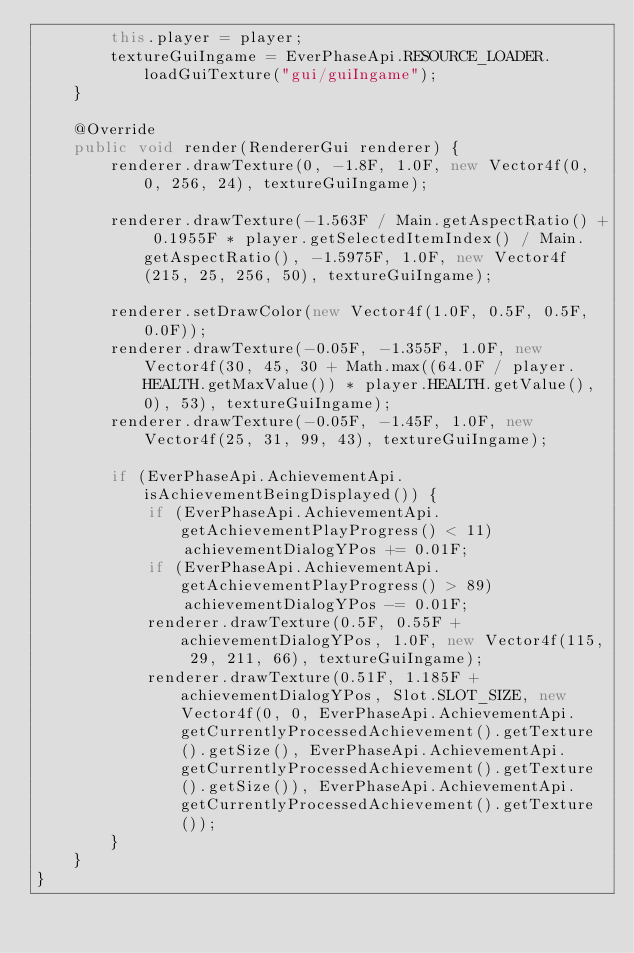<code> <loc_0><loc_0><loc_500><loc_500><_Java_>        this.player = player;
        textureGuiIngame = EverPhaseApi.RESOURCE_LOADER.loadGuiTexture("gui/guiIngame");
    }

    @Override
    public void render(RendererGui renderer) {
        renderer.drawTexture(0, -1.8F, 1.0F, new Vector4f(0, 0, 256, 24), textureGuiIngame);

        renderer.drawTexture(-1.563F / Main.getAspectRatio() + 0.1955F * player.getSelectedItemIndex() / Main.getAspectRatio(), -1.5975F, 1.0F, new Vector4f(215, 25, 256, 50), textureGuiIngame);

        renderer.setDrawColor(new Vector4f(1.0F, 0.5F, 0.5F, 0.0F));
        renderer.drawTexture(-0.05F, -1.355F, 1.0F, new Vector4f(30, 45, 30 + Math.max((64.0F / player.HEALTH.getMaxValue()) * player.HEALTH.getValue(), 0), 53), textureGuiIngame);
        renderer.drawTexture(-0.05F, -1.45F, 1.0F, new Vector4f(25, 31, 99, 43), textureGuiIngame);

        if (EverPhaseApi.AchievementApi.isAchievementBeingDisplayed()) {
            if (EverPhaseApi.AchievementApi.getAchievementPlayProgress() < 11)
                achievementDialogYPos += 0.01F;
            if (EverPhaseApi.AchievementApi.getAchievementPlayProgress() > 89)
                achievementDialogYPos -= 0.01F;
            renderer.drawTexture(0.5F, 0.55F + achievementDialogYPos, 1.0F, new Vector4f(115, 29, 211, 66), textureGuiIngame);
            renderer.drawTexture(0.51F, 1.185F + achievementDialogYPos, Slot.SLOT_SIZE, new Vector4f(0, 0, EverPhaseApi.AchievementApi.getCurrentlyProcessedAchievement().getTexture().getSize(), EverPhaseApi.AchievementApi.getCurrentlyProcessedAchievement().getTexture().getSize()), EverPhaseApi.AchievementApi.getCurrentlyProcessedAchievement().getTexture());
        }
    }
}
</code> 